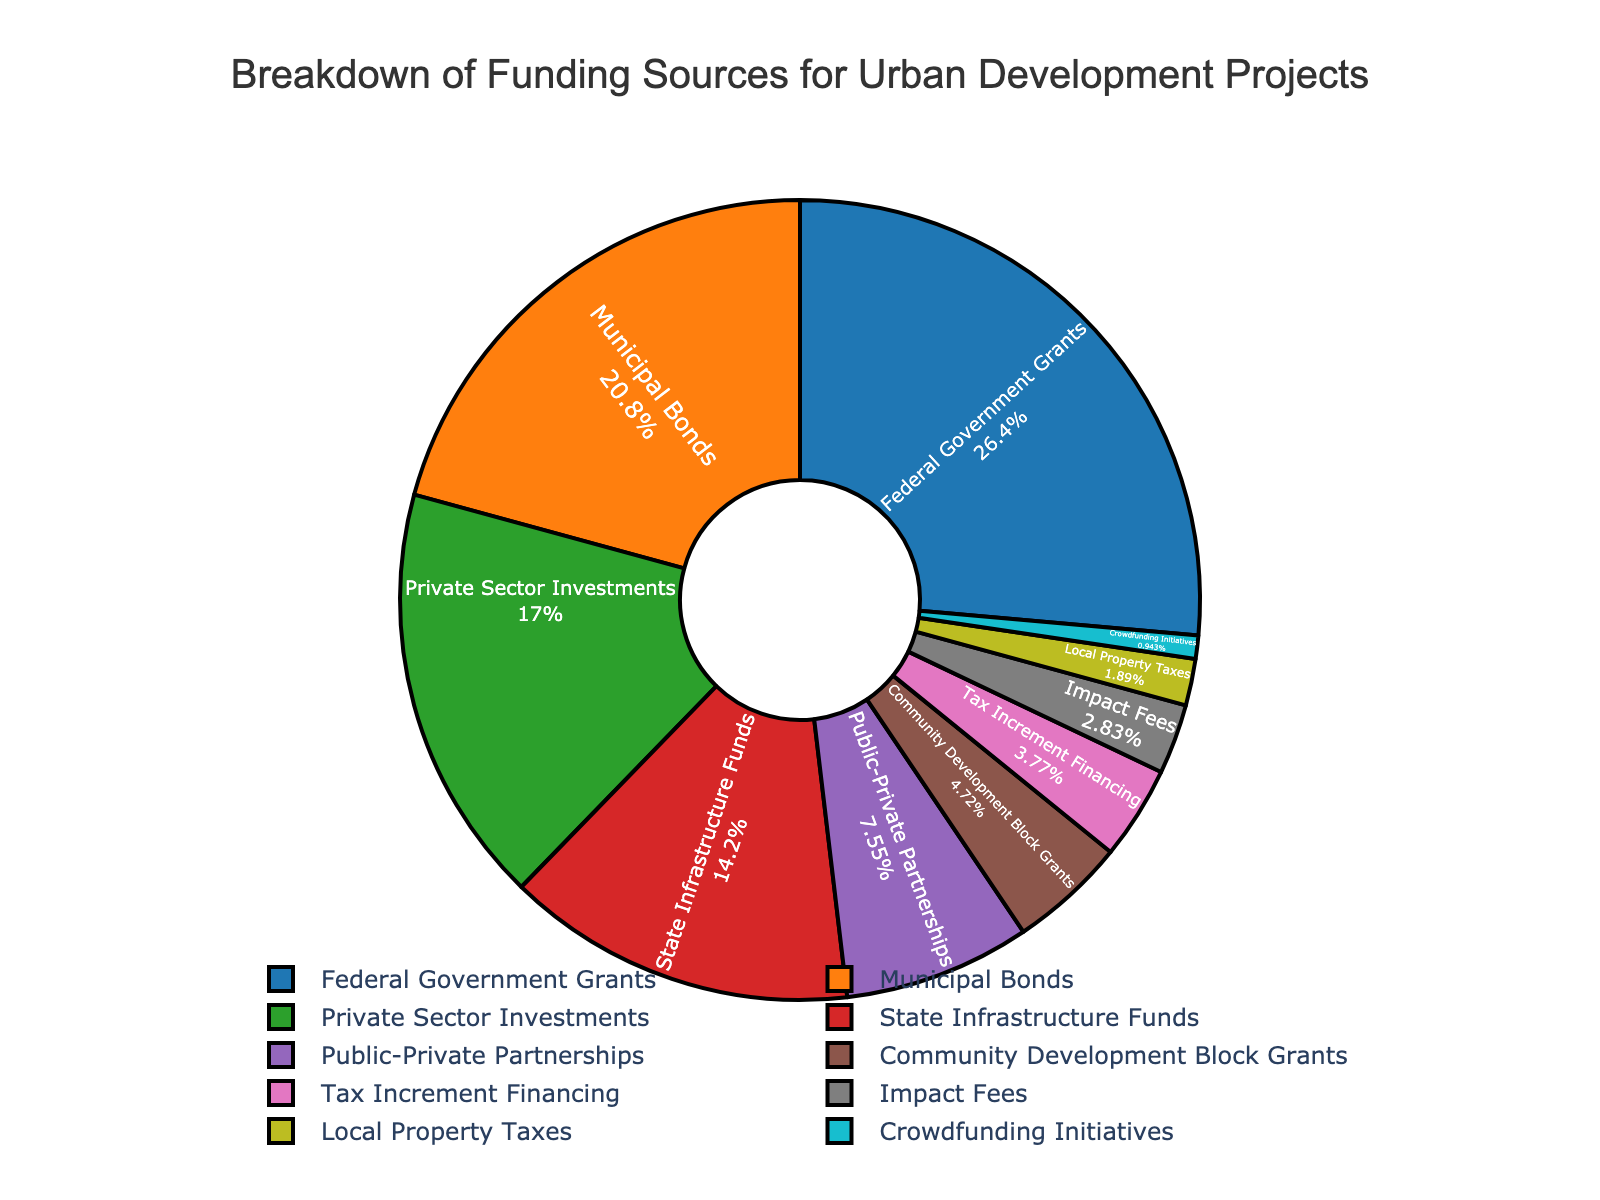What's the largest funding source for urban development projects? The figure shows that the largest segment belongs to the Federal Government Grants section. By looking at the values, it can be confirmed that the Federal Government Grants contribute 28%, which is the highest.
Answer: Federal Government Grants Which funding source has the lowest contribution? Crowdfunding Initiatives occupy the smallest segment of the pie chart. This funding source contributes 1%, which is lower than any other category.
Answer: Crowdfunding Initiatives What's the combined percentage of Municipal Bonds and Private Sector Investments? Municipal Bonds contribute 22%, and Private Sector Investments contribute 18%. Adding these two percentages together: 22% + 18% = 40%.
Answer: 40% Are the contributions of State Infrastructure Funds and Community Development Block Grants equal? State Infrastructure Funds contribute 15%, while Community Development Block Grants contribute 5%. Observing the figures, it is clear that these contributions are not equal, with State Infrastructure Funds being higher.
Answer: No Which funding source has a higher percentage, Tax Increment Financing or Impact Fees? Tax Increment Financing contributes 4%, whereas Impact Fees contribute 3%. Comparing these values, Tax Increment Financing is higher.
Answer: Tax Increment Financing What is the percentage difference between Federal Government Grants and State Infrastructure Funds? Federal Government Grants contribute 28%, and State Infrastructure Funds contribute 15%. Subtracting the smaller percentage from the larger one: 28% - 15% = 13%.
Answer: 13% What's the sum of percentages for the bottom three funding sources? The bottom three funding sources are Local Property Taxes (2%), Impact Fees (3%), and Crowdfunding Initiatives (1%). Adding these percentages together: 2% + 3% + 1% = 6%.
Answer: 6% Is the segment for Public-Private Partnerships larger than the segment for Community Development Block Grants? Public-Private Partnerships contribute 8%, and Community Development Block Grants contribute 5%. Observing the size of the segments, Public-Private Partnerships have a larger segment.
Answer: Yes If you combine Private Sector Investments and Public-Private Partnerships, does it exceed the contribution of Municipal Bonds? Private Sector Investments contribute 18% and Public-Private Partnerships contribute 8%. Their combined contribution is: 18% + 8% = 26%. Municipal Bonds contribute 22%. Comparing these, the combined contribution of Private Sector Investments and Public-Private Partnerships (26%) exceeds that of Municipal Bonds (22%).
Answer: Yes 